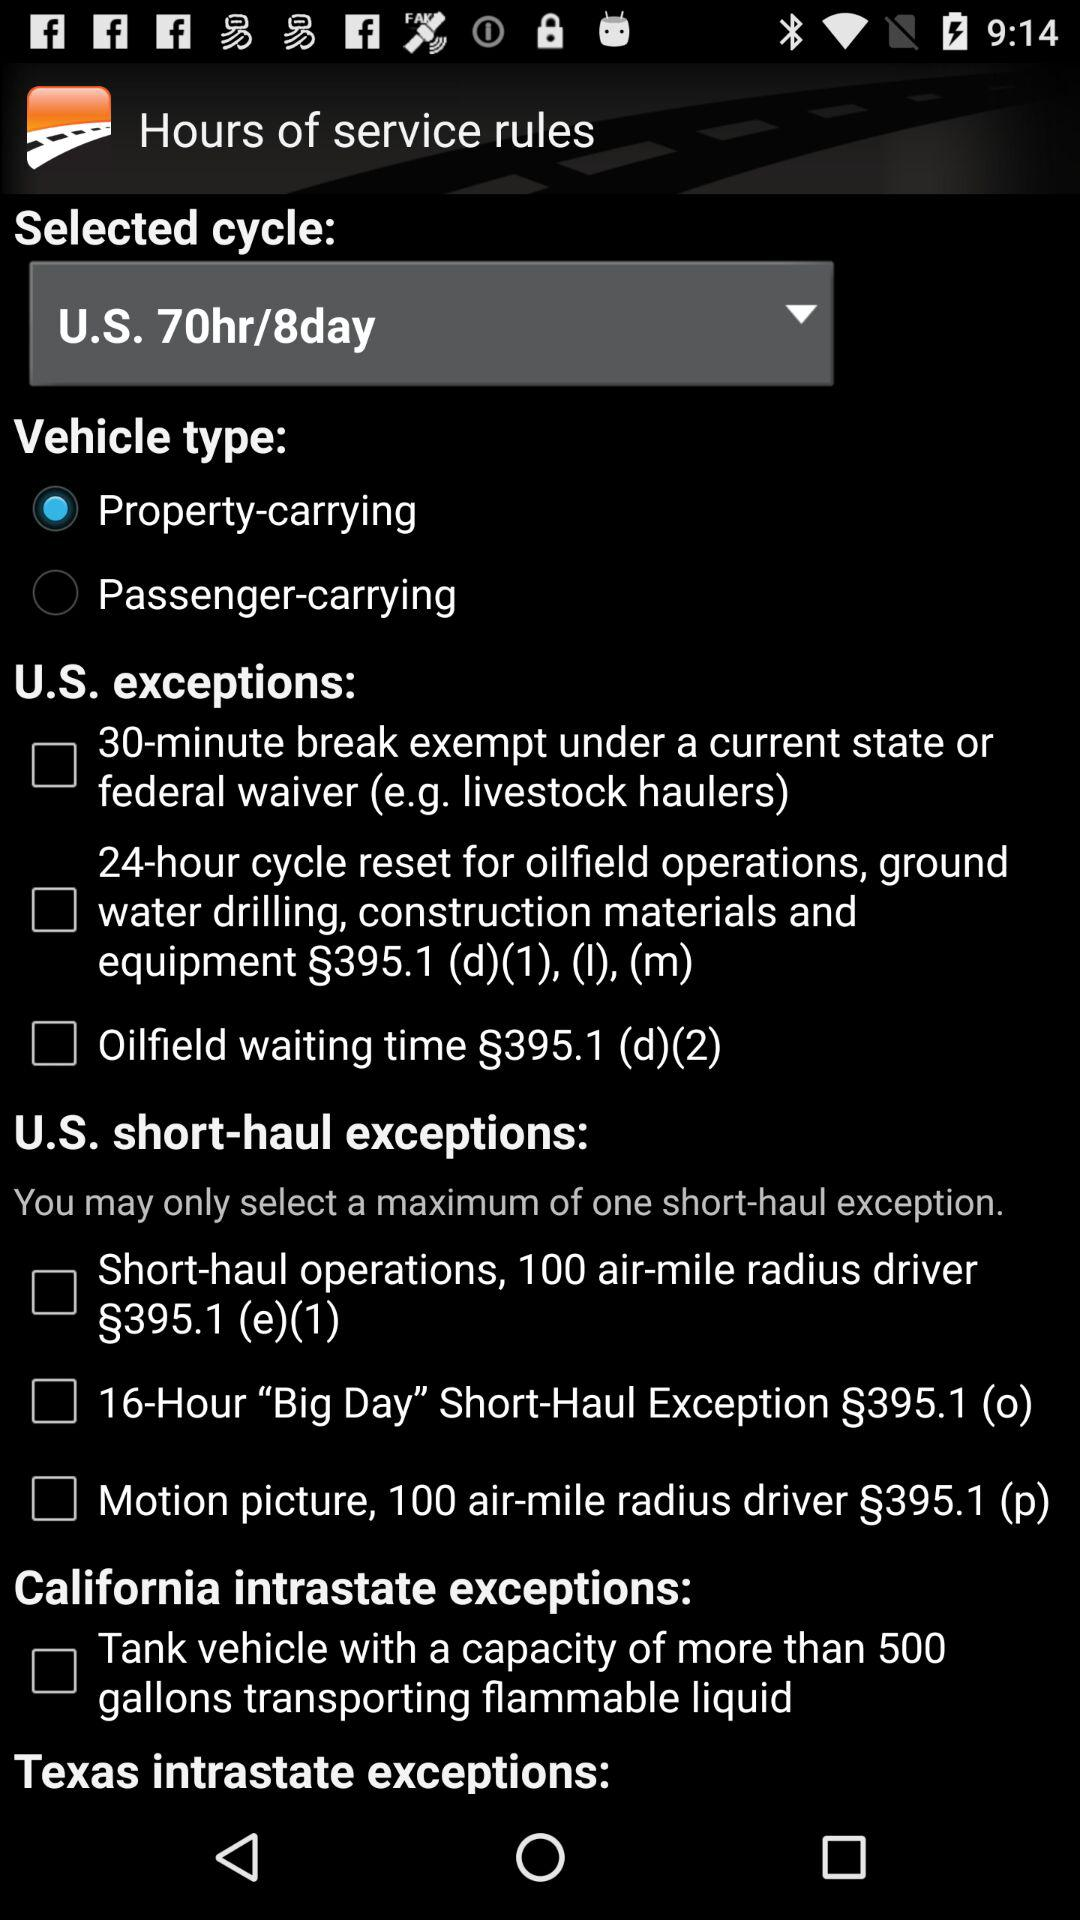How many short-haul exceptions are there?
Answer the question using a single word or phrase. 3 